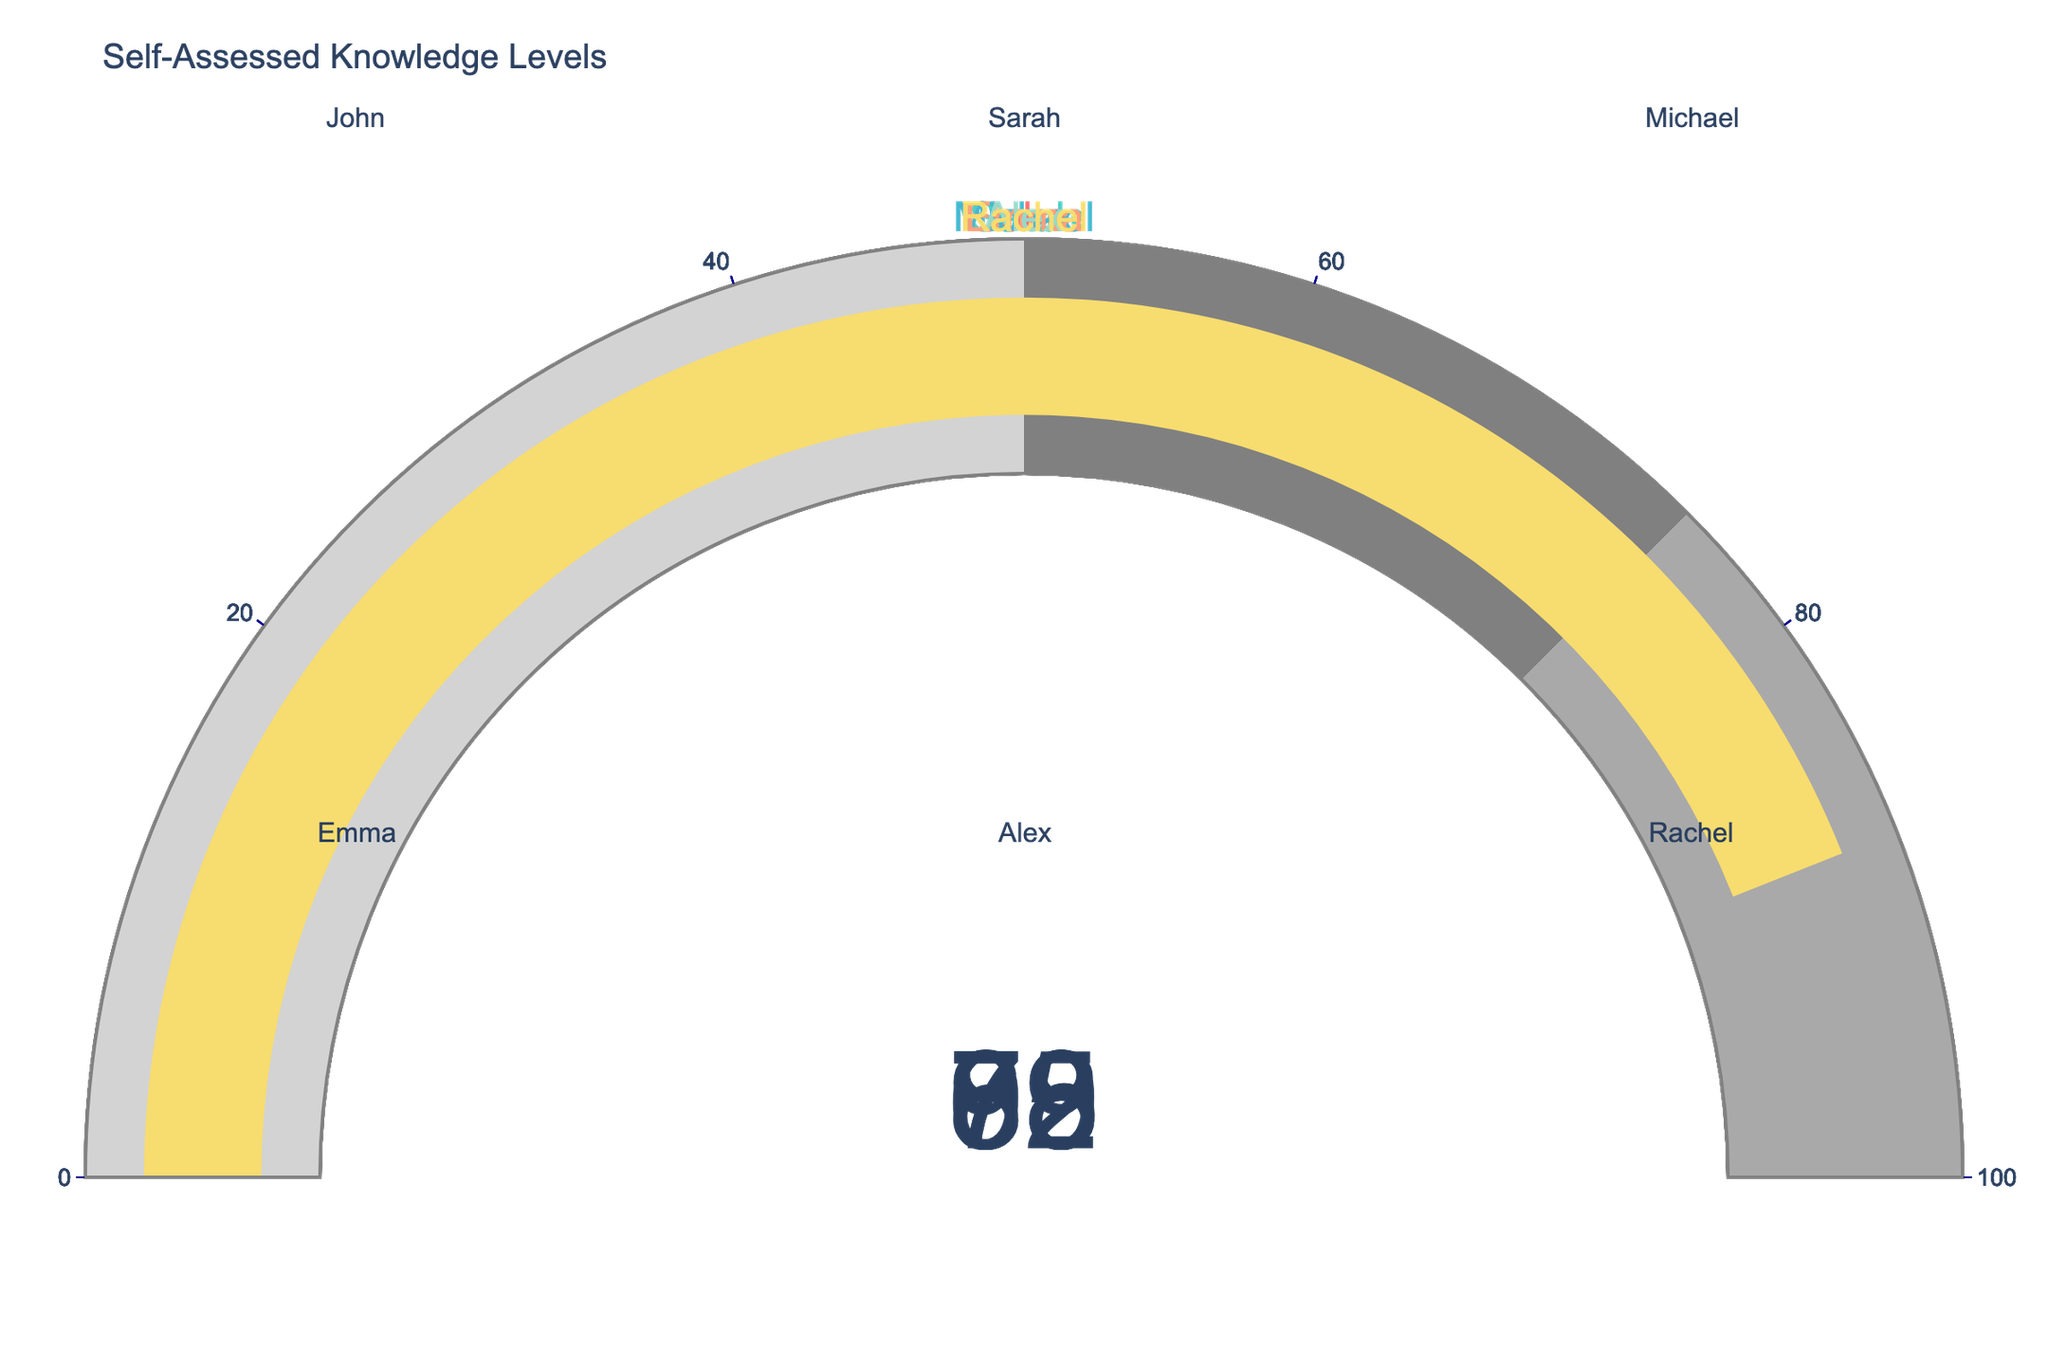What is the self-assessed knowledge level of John? John's gauge indicates a value in the center which is labeled with his self-assessed knowledge level.
Answer: 85 Who has the highest self-assessed knowledge level? Compare the gauge values of all members. Michael's gauge shows the highest value.
Answer: Michael What is the average self-assessed knowledge level of all members? Sum up all values: 85 + 72 + 93 + 68 + 79 + 88 = 485, then divide by the number of members (6).
Answer: 80.83 How many members have a self-assessed knowledge level above 80? Identify gauges with values above 80: John (85), Michael (93), Rachel (88).
Answer: 3 Who has a self-assessed knowledge level closest to 75? Check the values and compare the differences: Sarah (72) is closest to 75.
Answer: Sarah What is the range of self-assessed knowledge levels? Subtract the lowest value (68) from the highest value (93).
Answer: 25 Which two members' self-assessed knowledge levels differ the most? Calculate the differences between all pairs and identify the maximum difference: Michael (93) and Emma (68) have a difference of 25.
Answer: Michael and Emma What is the median self-assessed knowledge level of all members? Sort the values: 68, 72, 79, 85, 88, 93. The median is the average of the 3rd and 4th values: (79 + 85) / 2 = 82.
Answer: 82 Is there any member whose self-assessed knowledge level is below 70? Check the gauges for values below 70: Emma (68) is the only one.
Answer: Yes, Emma 